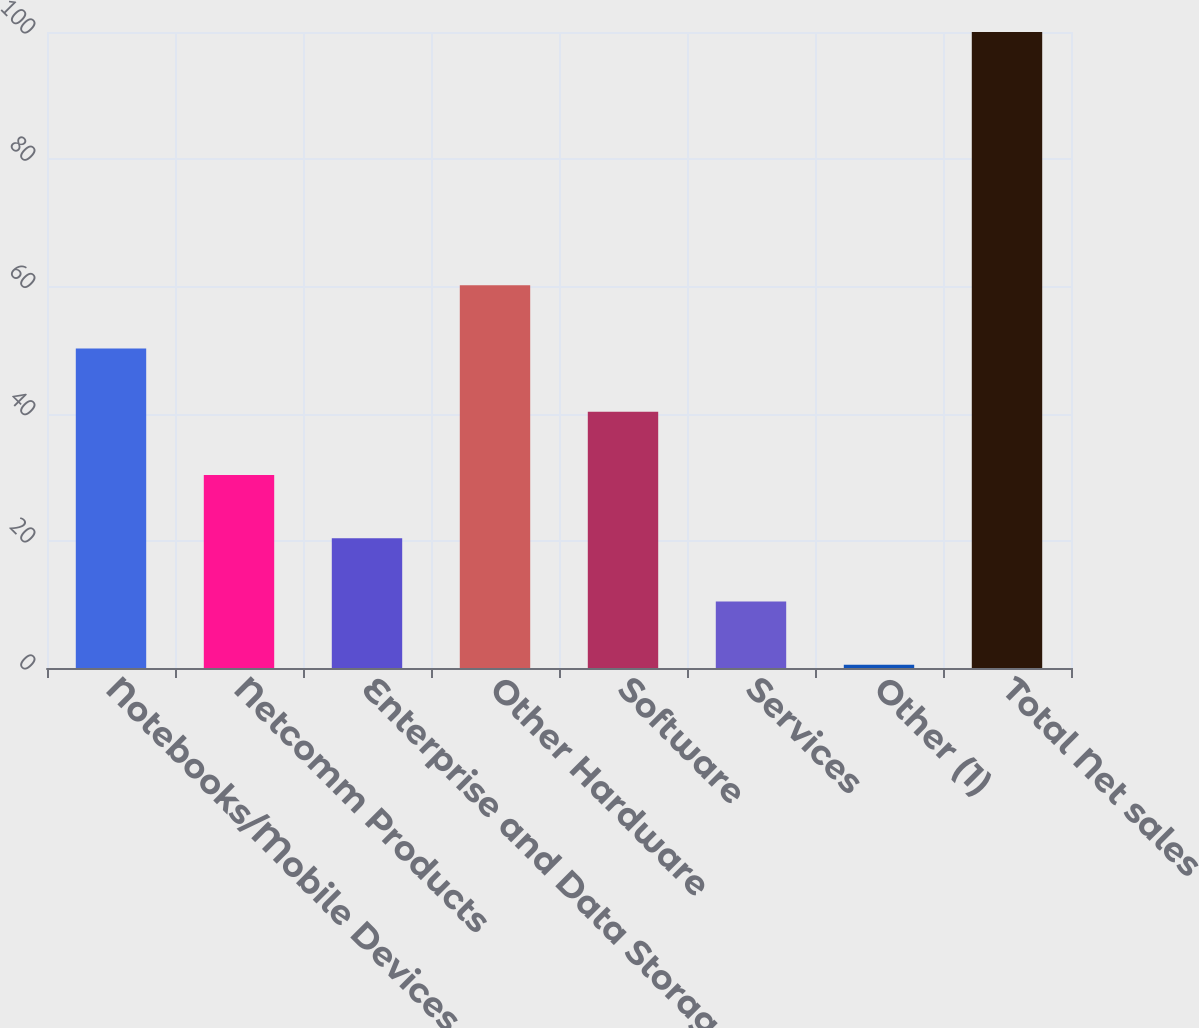Convert chart to OTSL. <chart><loc_0><loc_0><loc_500><loc_500><bar_chart><fcel>Notebooks/Mobile Devices<fcel>Netcomm Products<fcel>Enterprise and Data Storage<fcel>Other Hardware<fcel>Software<fcel>Services<fcel>Other (1)<fcel>Total Net sales<nl><fcel>50.25<fcel>30.35<fcel>20.4<fcel>60.2<fcel>40.3<fcel>10.45<fcel>0.5<fcel>100<nl></chart> 